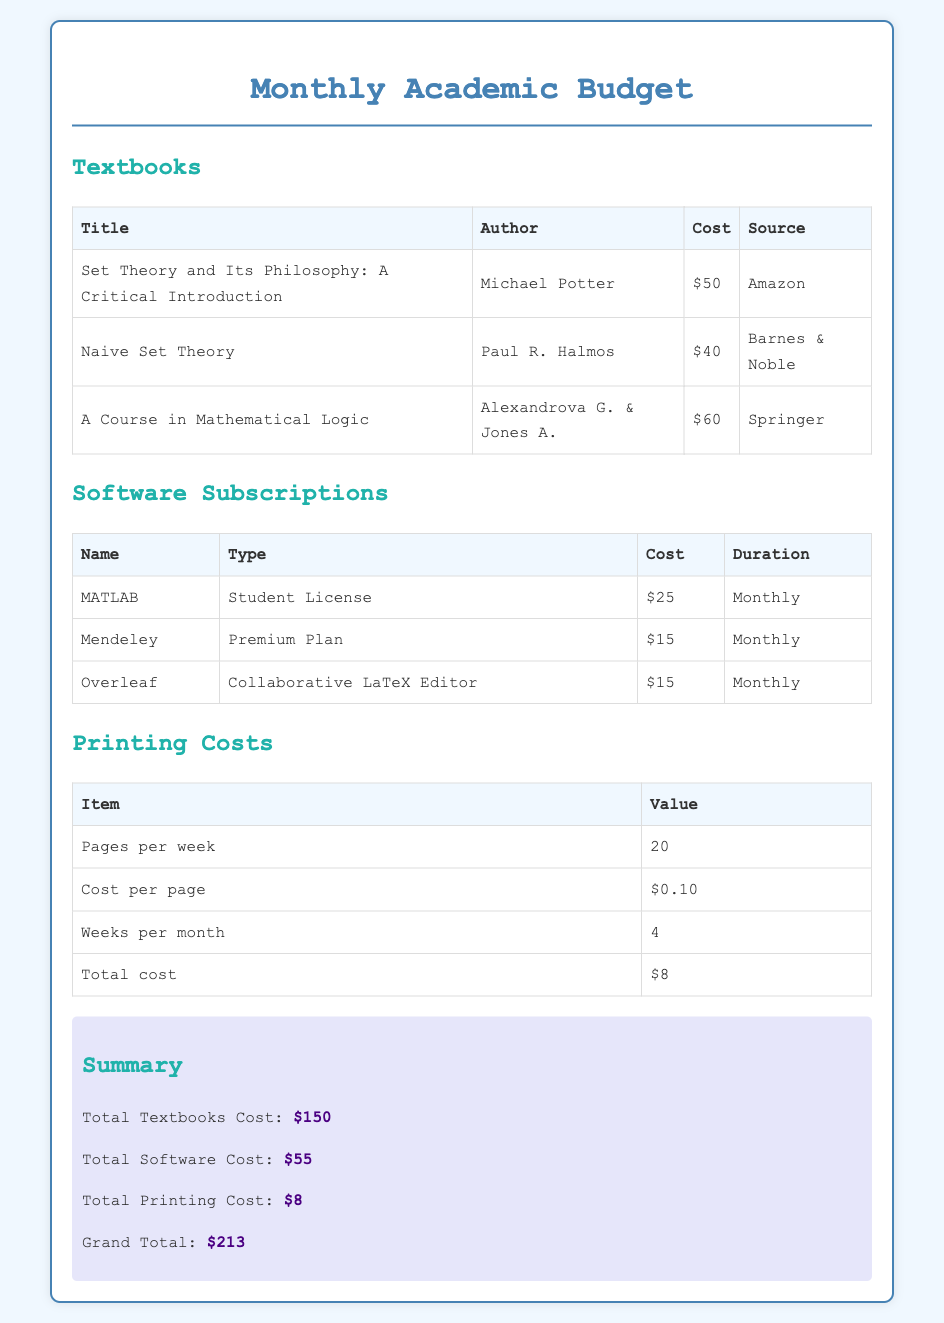What is the total cost of textbooks? The total cost of textbooks is calculated from the individual prices listed for each textbook, which sums up to $150.
Answer: $150 Who is the author of "Naive Set Theory"? The author of "Naive Set Theory" is Paul R. Halmos, as stated in the document.
Answer: Paul R. Halmos What is the cost of the MATLAB subscription? The cost of the MATLAB subscription appears in the software subscriptions table, which shows it as $25.
Answer: $25 How many pages are printed per week? The document specifies that 20 pages are printed per week, as shown in the printing costs table.
Answer: 20 What is the total printing cost? The total printing cost is derived from the information in the printing costs section, which shows a cost of $8.
Answer: $8 Which software subscription has the lowest cost? The software subscription with the lowest cost is either Mendeley or Overleaf, both at $15.
Answer: $15 What is the grand total of the academic budget? The grand total is the sum of all costs listed, which adds up to $213.
Answer: $213 What type of resource is "Set Theory and Its Philosophy: A Critical Introduction"? It is categorized as a textbook, as indicated in the textbooks section.
Answer: Textbook How many weeks are there in a month according to the document? The document mentions 4 weeks per month in the printing costs section.
Answer: 4 